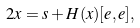Convert formula to latex. <formula><loc_0><loc_0><loc_500><loc_500>2 x = s + H ( x ) [ e , e ] ,</formula> 